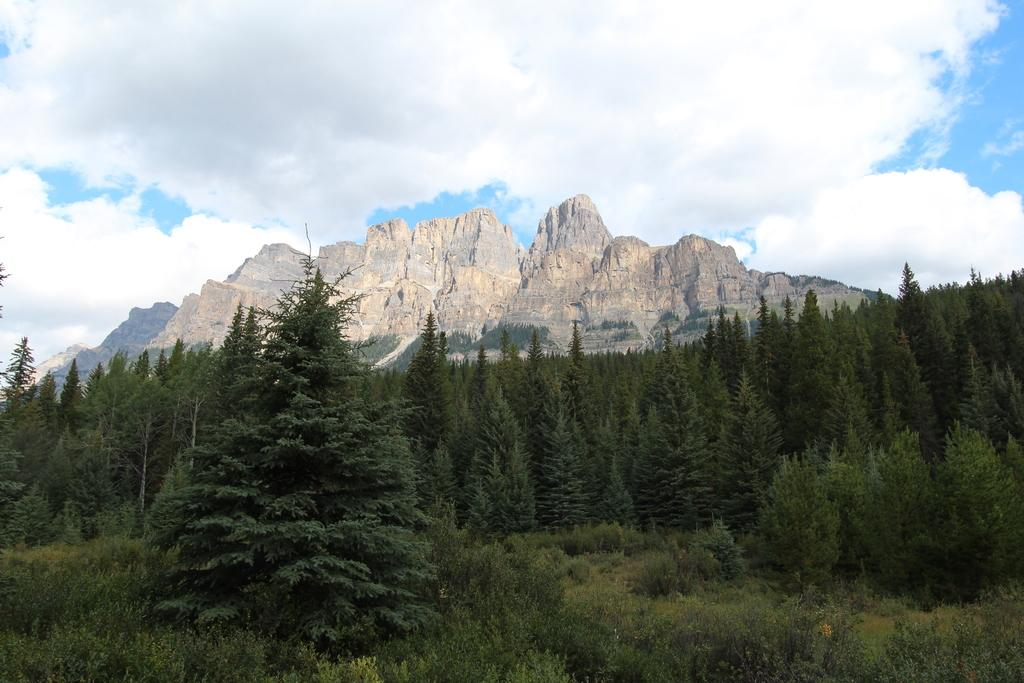What is the main subject of the image? The main subject of the image is a beautiful view of the mountains. What can be seen at the bottom of the image? There are many trees in the front bottom side of the image. What is visible at the top of the image? The sky is visible at the top of the image. Where is the zoo located in the image? There is no zoo present in the image; it features a view of mountains and trees. What type of balls can be seen rolling down the mountainside in the image? There are no balls visible in the image; it only shows a view of mountains, trees, and the sky. 